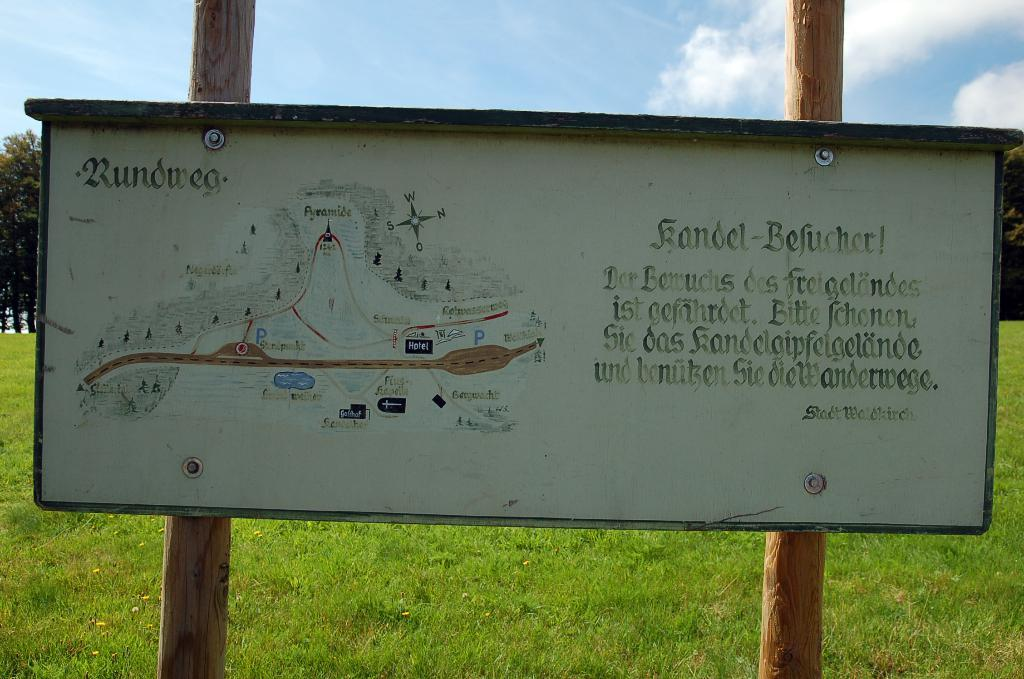What is the main object in the image? There is a board in the image. What is on the board? Something is written on the board. How is the board supported? The board is attached to wooden logs. What can be seen in the background of the image? There is green grass and trees visible in the background. What is the color of the sky in the image? The sky is blue and white in color. How many cakes are placed on the board in the image? There are no cakes present on the board in the image. What type of banana is hanging from the trees in the background? There are no bananas visible in the image; only trees are present in the background. 